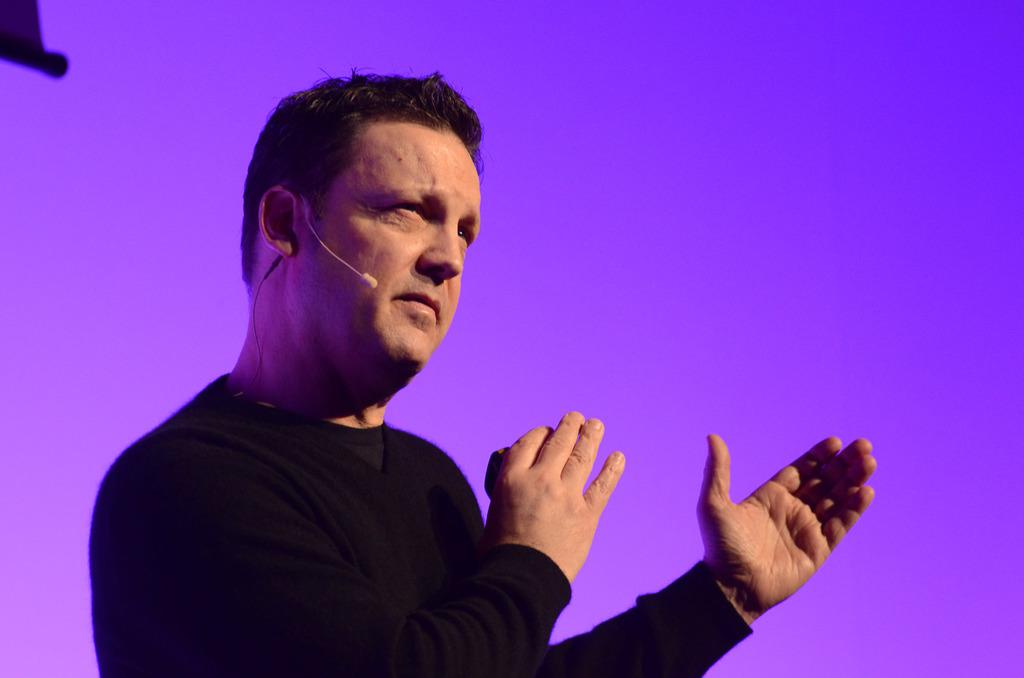What is the main subject of the image? There is a man in the image. What is the man wearing in the image? The man is wearing a black t-shirt. Can you describe the background of the image? The background of the image is purple and pink. What can be seen at the top left of the image? There is an object at the top left of the image. What type of jeans is the man wearing in the image? The facts provided do not mention any jeans; the man is wearing a black t-shirt. What is the man shaking in the image? There is no indication in the image that the man is shaking anything. 